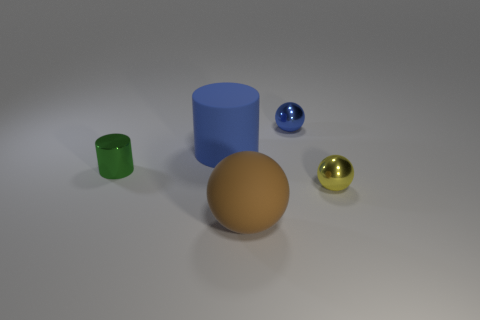What number of things are either rubber things or objects that are behind the large ball?
Ensure brevity in your answer.  5. How many large things are the same shape as the tiny green thing?
Ensure brevity in your answer.  1. There is another sphere that is the same size as the yellow ball; what is its material?
Your response must be concise. Metal. What size is the rubber thing that is in front of the large matte object behind the matte object that is in front of the green object?
Your answer should be compact. Large. Does the rubber object to the left of the brown thing have the same color as the small ball behind the small shiny cylinder?
Provide a short and direct response. Yes. How many brown things are either small metallic objects or big rubber cylinders?
Make the answer very short. 0. What number of things have the same size as the metallic cylinder?
Ensure brevity in your answer.  2. Is the material of the small ball that is to the left of the yellow shiny sphere the same as the brown ball?
Offer a terse response. No. There is a metallic sphere in front of the tiny blue object; are there any tiny green metallic things on the right side of it?
Give a very brief answer. No. There is a brown object that is the same shape as the small yellow thing; what material is it?
Provide a short and direct response. Rubber. 